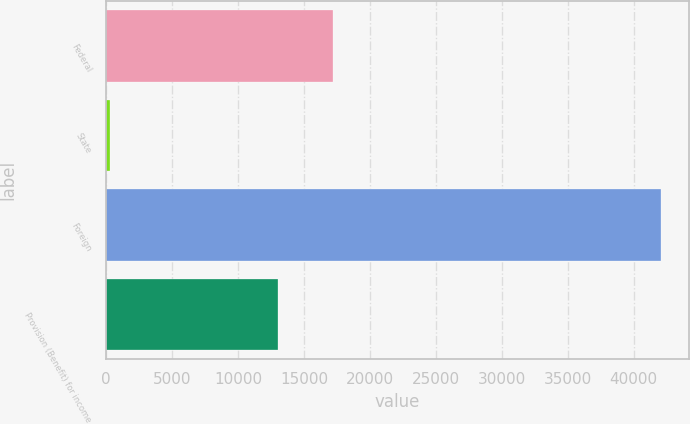Convert chart to OTSL. <chart><loc_0><loc_0><loc_500><loc_500><bar_chart><fcel>Federal<fcel>State<fcel>Foreign<fcel>Provision (Benefit) for income<nl><fcel>17198.6<fcel>279<fcel>42085<fcel>13018<nl></chart> 